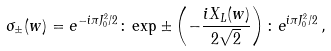<formula> <loc_0><loc_0><loc_500><loc_500>\sigma _ { \pm } ( w ) = e ^ { - i \pi J ^ { 2 } _ { 0 } / 2 } \colon \exp \pm \left ( - \frac { i X _ { L } ( w ) } { 2 \sqrt { 2 } } \right ) \colon e ^ { i \pi J ^ { 2 } _ { 0 } / 2 } \, ,</formula> 